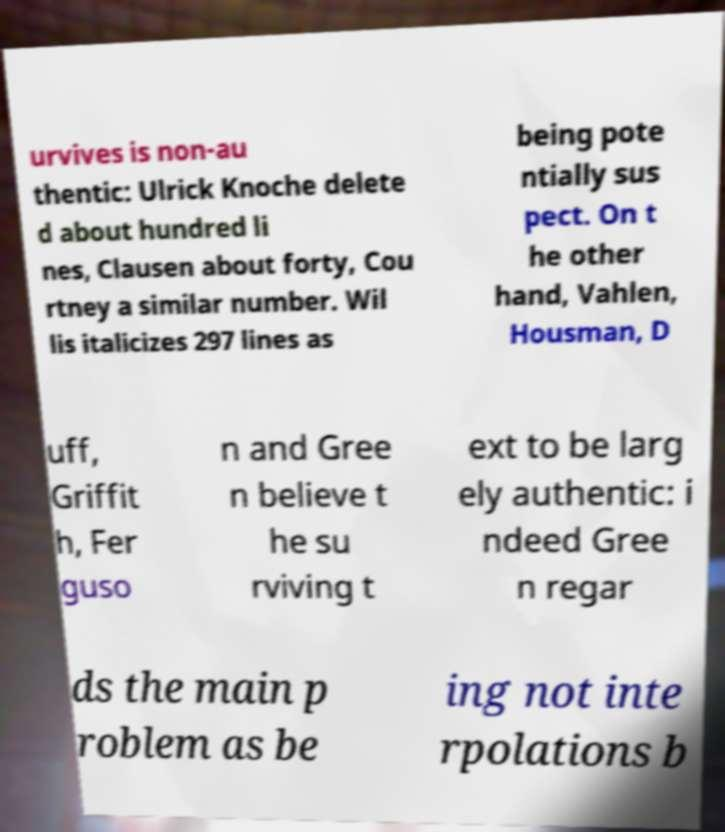There's text embedded in this image that I need extracted. Can you transcribe it verbatim? urvives is non-au thentic: Ulrick Knoche delete d about hundred li nes, Clausen about forty, Cou rtney a similar number. Wil lis italicizes 297 lines as being pote ntially sus pect. On t he other hand, Vahlen, Housman, D uff, Griffit h, Fer guso n and Gree n believe t he su rviving t ext to be larg ely authentic: i ndeed Gree n regar ds the main p roblem as be ing not inte rpolations b 